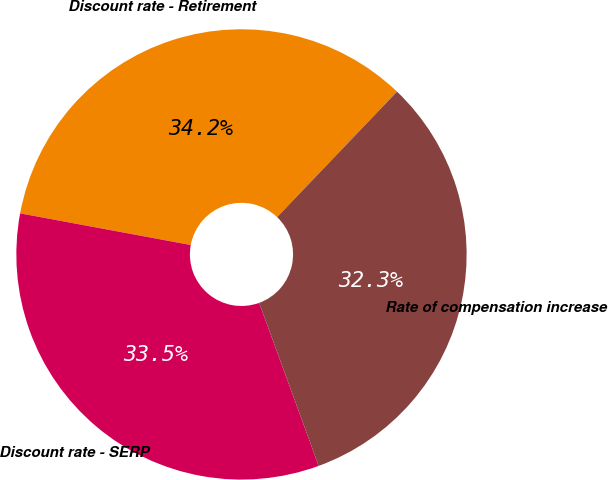Convert chart. <chart><loc_0><loc_0><loc_500><loc_500><pie_chart><fcel>Discount rate - Retirement<fcel>Discount rate - SERP<fcel>Rate of compensation increase<nl><fcel>34.22%<fcel>33.49%<fcel>32.29%<nl></chart> 